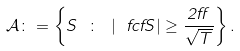Convert formula to latex. <formula><loc_0><loc_0><loc_500><loc_500>\mathcal { A } \colon = \left \{ S \ \colon \ | \ f c { f } { S } | \geq \frac { 2 \alpha } { \sqrt { T } } \right \} .</formula> 